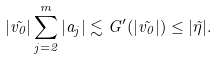<formula> <loc_0><loc_0><loc_500><loc_500>| \vec { v _ { 0 } } | \sum _ { j = 2 } ^ { m } | a _ { j } | \lesssim G ^ { \prime } ( | \vec { v _ { 0 } } | ) \leq | \vec { \eta } | .</formula> 